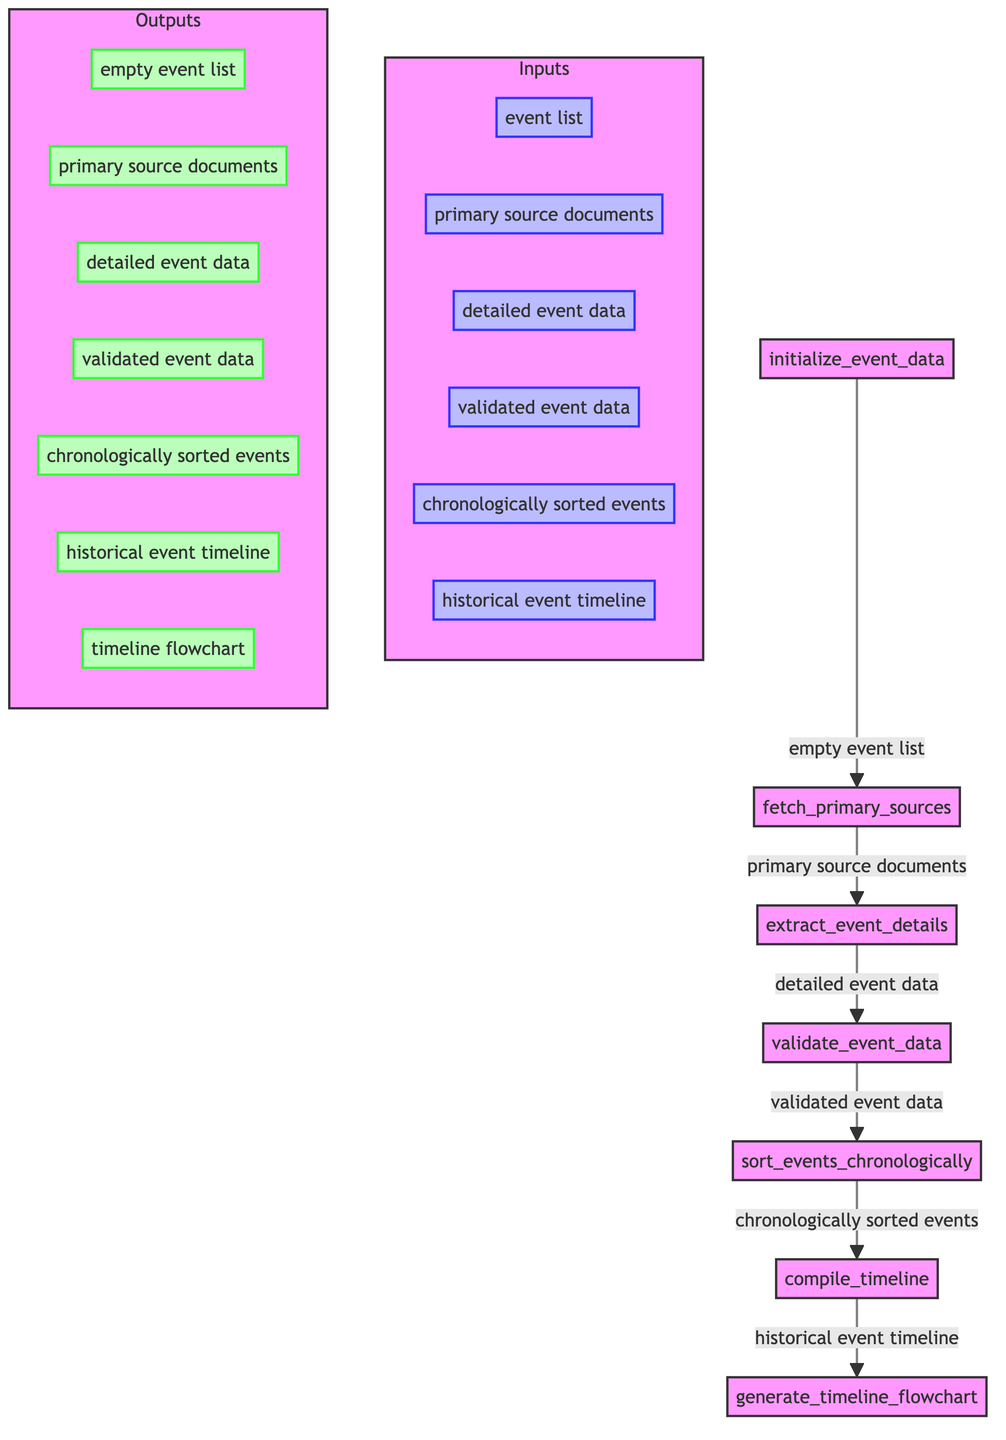What is the first step in the flowchart? The first step in the flowchart is "initialize_event_data," which begins the process of compiling a historical event timeline. This node represents the initial action in the sequence of tasks.
Answer: initialize_event_data How many nodes are present in the flowchart? By counting the distinct steps in the flowchart, we identify a total of seven nodes representing different tasks. Each node signifies a specific action within the overall process.
Answer: seven What is the output of the "fetch_primary_sources" node? The output of the "fetch_primary_sources" node is "primary source documents," indicating that this step retrieves documents necessary for further processing.
Answer: primary source documents Which node follows the "validate_event_data" step? The node that follows "validate_event_data" is "sort_events_chronologically." This sequence indicates that once the data is validated, it is subsequently organized chronologically.
Answer: sort_events_chronologically What is the input to the "compile_timeline" node? The input to the "compile_timeline" node is "chronologically sorted events," which signifies that this process utilizes previously organized events to create a timeline.
Answer: chronologically sorted events What is the final output of the flowchart? The final output of the flowchart is "timeline flowchart," which is generated from the historical event timeline compiled in previous steps, representing the completed process.
Answer: timeline flowchart Which step validates the event details? The step that validates the event details is "validate_event_data." This action checks the accuracy of the data against secondary sources.
Answer: validate_event_data What is the relationship between "extract_event_details" and "validate_event_data"? The relationship is sequential; "extract_event_details" must occur first to provide the "detailed event data" input for the subsequent "validate_event_data" step. This order shows a dependency where one action is based on the completion of another.
Answer: sequential dependency What type of documents are retrieved in the second step? The type of documents retrieved in the second step is "primary source documents," which are essential for extracting details about historical events.
Answer: primary source documents 